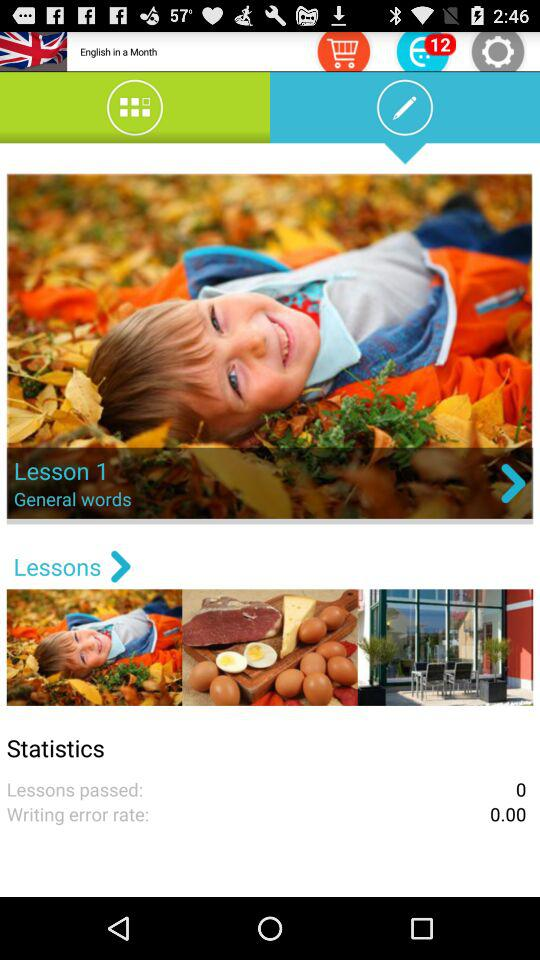How many lessons have been passed?
Answer the question using a single word or phrase. 0 